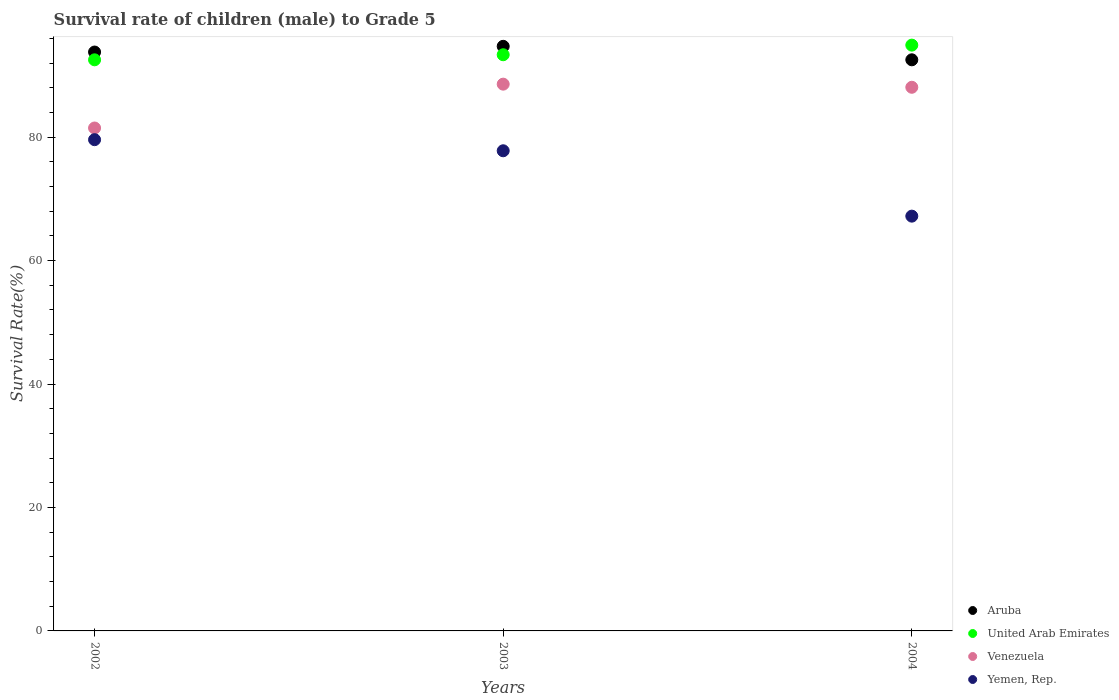How many different coloured dotlines are there?
Ensure brevity in your answer.  4. Is the number of dotlines equal to the number of legend labels?
Your response must be concise. Yes. What is the survival rate of male children to grade 5 in United Arab Emirates in 2004?
Ensure brevity in your answer.  94.91. Across all years, what is the maximum survival rate of male children to grade 5 in Venezuela?
Your response must be concise. 88.59. Across all years, what is the minimum survival rate of male children to grade 5 in Aruba?
Your answer should be compact. 92.53. What is the total survival rate of male children to grade 5 in Yemen, Rep. in the graph?
Offer a terse response. 224.59. What is the difference between the survival rate of male children to grade 5 in Aruba in 2002 and that in 2003?
Make the answer very short. -0.93. What is the difference between the survival rate of male children to grade 5 in Venezuela in 2004 and the survival rate of male children to grade 5 in Aruba in 2002?
Keep it short and to the point. -5.71. What is the average survival rate of male children to grade 5 in Yemen, Rep. per year?
Offer a terse response. 74.86. In the year 2004, what is the difference between the survival rate of male children to grade 5 in Yemen, Rep. and survival rate of male children to grade 5 in United Arab Emirates?
Your answer should be compact. -27.71. What is the ratio of the survival rate of male children to grade 5 in United Arab Emirates in 2002 to that in 2003?
Ensure brevity in your answer.  0.99. Is the survival rate of male children to grade 5 in Aruba in 2002 less than that in 2004?
Your response must be concise. No. What is the difference between the highest and the second highest survival rate of male children to grade 5 in United Arab Emirates?
Your answer should be very brief. 1.56. What is the difference between the highest and the lowest survival rate of male children to grade 5 in Aruba?
Provide a succinct answer. 2.18. Is it the case that in every year, the sum of the survival rate of male children to grade 5 in Venezuela and survival rate of male children to grade 5 in Aruba  is greater than the survival rate of male children to grade 5 in United Arab Emirates?
Your response must be concise. Yes. Does the survival rate of male children to grade 5 in Venezuela monotonically increase over the years?
Your answer should be compact. No. Is the survival rate of male children to grade 5 in Yemen, Rep. strictly greater than the survival rate of male children to grade 5 in United Arab Emirates over the years?
Offer a terse response. No. How many dotlines are there?
Make the answer very short. 4. Are the values on the major ticks of Y-axis written in scientific E-notation?
Offer a very short reply. No. Does the graph contain any zero values?
Your response must be concise. No. How many legend labels are there?
Make the answer very short. 4. How are the legend labels stacked?
Give a very brief answer. Vertical. What is the title of the graph?
Your answer should be compact. Survival rate of children (male) to Grade 5. What is the label or title of the X-axis?
Offer a terse response. Years. What is the label or title of the Y-axis?
Provide a short and direct response. Survival Rate(%). What is the Survival Rate(%) in Aruba in 2002?
Your answer should be very brief. 93.79. What is the Survival Rate(%) in United Arab Emirates in 2002?
Your response must be concise. 92.53. What is the Survival Rate(%) in Venezuela in 2002?
Your response must be concise. 81.48. What is the Survival Rate(%) in Yemen, Rep. in 2002?
Offer a terse response. 79.59. What is the Survival Rate(%) of Aruba in 2003?
Your answer should be compact. 94.72. What is the Survival Rate(%) of United Arab Emirates in 2003?
Your answer should be compact. 93.35. What is the Survival Rate(%) of Venezuela in 2003?
Provide a succinct answer. 88.59. What is the Survival Rate(%) in Yemen, Rep. in 2003?
Your response must be concise. 77.79. What is the Survival Rate(%) of Aruba in 2004?
Provide a short and direct response. 92.53. What is the Survival Rate(%) in United Arab Emirates in 2004?
Your answer should be very brief. 94.91. What is the Survival Rate(%) in Venezuela in 2004?
Offer a very short reply. 88.08. What is the Survival Rate(%) of Yemen, Rep. in 2004?
Keep it short and to the point. 67.2. Across all years, what is the maximum Survival Rate(%) of Aruba?
Provide a short and direct response. 94.72. Across all years, what is the maximum Survival Rate(%) in United Arab Emirates?
Provide a succinct answer. 94.91. Across all years, what is the maximum Survival Rate(%) of Venezuela?
Offer a terse response. 88.59. Across all years, what is the maximum Survival Rate(%) in Yemen, Rep.?
Ensure brevity in your answer.  79.59. Across all years, what is the minimum Survival Rate(%) in Aruba?
Offer a very short reply. 92.53. Across all years, what is the minimum Survival Rate(%) of United Arab Emirates?
Your response must be concise. 92.53. Across all years, what is the minimum Survival Rate(%) in Venezuela?
Offer a very short reply. 81.48. Across all years, what is the minimum Survival Rate(%) in Yemen, Rep.?
Make the answer very short. 67.2. What is the total Survival Rate(%) of Aruba in the graph?
Ensure brevity in your answer.  281.04. What is the total Survival Rate(%) of United Arab Emirates in the graph?
Your answer should be compact. 280.79. What is the total Survival Rate(%) of Venezuela in the graph?
Provide a succinct answer. 258.15. What is the total Survival Rate(%) in Yemen, Rep. in the graph?
Ensure brevity in your answer.  224.59. What is the difference between the Survival Rate(%) of Aruba in 2002 and that in 2003?
Provide a short and direct response. -0.93. What is the difference between the Survival Rate(%) in United Arab Emirates in 2002 and that in 2003?
Your response must be concise. -0.82. What is the difference between the Survival Rate(%) in Venezuela in 2002 and that in 2003?
Your answer should be compact. -7.1. What is the difference between the Survival Rate(%) of Yemen, Rep. in 2002 and that in 2003?
Give a very brief answer. 1.8. What is the difference between the Survival Rate(%) in Aruba in 2002 and that in 2004?
Your response must be concise. 1.26. What is the difference between the Survival Rate(%) of United Arab Emirates in 2002 and that in 2004?
Your answer should be compact. -2.38. What is the difference between the Survival Rate(%) of Venezuela in 2002 and that in 2004?
Provide a short and direct response. -6.6. What is the difference between the Survival Rate(%) of Yemen, Rep. in 2002 and that in 2004?
Provide a succinct answer. 12.39. What is the difference between the Survival Rate(%) in Aruba in 2003 and that in 2004?
Ensure brevity in your answer.  2.18. What is the difference between the Survival Rate(%) of United Arab Emirates in 2003 and that in 2004?
Keep it short and to the point. -1.56. What is the difference between the Survival Rate(%) of Venezuela in 2003 and that in 2004?
Provide a succinct answer. 0.51. What is the difference between the Survival Rate(%) in Yemen, Rep. in 2003 and that in 2004?
Offer a terse response. 10.59. What is the difference between the Survival Rate(%) in Aruba in 2002 and the Survival Rate(%) in United Arab Emirates in 2003?
Your answer should be very brief. 0.44. What is the difference between the Survival Rate(%) in Aruba in 2002 and the Survival Rate(%) in Venezuela in 2003?
Provide a succinct answer. 5.2. What is the difference between the Survival Rate(%) in Aruba in 2002 and the Survival Rate(%) in Yemen, Rep. in 2003?
Make the answer very short. 16. What is the difference between the Survival Rate(%) in United Arab Emirates in 2002 and the Survival Rate(%) in Venezuela in 2003?
Ensure brevity in your answer.  3.94. What is the difference between the Survival Rate(%) in United Arab Emirates in 2002 and the Survival Rate(%) in Yemen, Rep. in 2003?
Your response must be concise. 14.74. What is the difference between the Survival Rate(%) in Venezuela in 2002 and the Survival Rate(%) in Yemen, Rep. in 2003?
Your answer should be very brief. 3.69. What is the difference between the Survival Rate(%) of Aruba in 2002 and the Survival Rate(%) of United Arab Emirates in 2004?
Your response must be concise. -1.12. What is the difference between the Survival Rate(%) of Aruba in 2002 and the Survival Rate(%) of Venezuela in 2004?
Your response must be concise. 5.71. What is the difference between the Survival Rate(%) in Aruba in 2002 and the Survival Rate(%) in Yemen, Rep. in 2004?
Provide a succinct answer. 26.59. What is the difference between the Survival Rate(%) in United Arab Emirates in 2002 and the Survival Rate(%) in Venezuela in 2004?
Make the answer very short. 4.45. What is the difference between the Survival Rate(%) of United Arab Emirates in 2002 and the Survival Rate(%) of Yemen, Rep. in 2004?
Offer a very short reply. 25.33. What is the difference between the Survival Rate(%) of Venezuela in 2002 and the Survival Rate(%) of Yemen, Rep. in 2004?
Keep it short and to the point. 14.28. What is the difference between the Survival Rate(%) of Aruba in 2003 and the Survival Rate(%) of United Arab Emirates in 2004?
Provide a succinct answer. -0.19. What is the difference between the Survival Rate(%) of Aruba in 2003 and the Survival Rate(%) of Venezuela in 2004?
Keep it short and to the point. 6.64. What is the difference between the Survival Rate(%) in Aruba in 2003 and the Survival Rate(%) in Yemen, Rep. in 2004?
Offer a terse response. 27.51. What is the difference between the Survival Rate(%) in United Arab Emirates in 2003 and the Survival Rate(%) in Venezuela in 2004?
Your response must be concise. 5.27. What is the difference between the Survival Rate(%) of United Arab Emirates in 2003 and the Survival Rate(%) of Yemen, Rep. in 2004?
Offer a terse response. 26.15. What is the difference between the Survival Rate(%) in Venezuela in 2003 and the Survival Rate(%) in Yemen, Rep. in 2004?
Provide a short and direct response. 21.38. What is the average Survival Rate(%) in Aruba per year?
Give a very brief answer. 93.68. What is the average Survival Rate(%) in United Arab Emirates per year?
Make the answer very short. 93.6. What is the average Survival Rate(%) of Venezuela per year?
Provide a succinct answer. 86.05. What is the average Survival Rate(%) of Yemen, Rep. per year?
Your response must be concise. 74.86. In the year 2002, what is the difference between the Survival Rate(%) of Aruba and Survival Rate(%) of United Arab Emirates?
Keep it short and to the point. 1.26. In the year 2002, what is the difference between the Survival Rate(%) of Aruba and Survival Rate(%) of Venezuela?
Ensure brevity in your answer.  12.31. In the year 2002, what is the difference between the Survival Rate(%) in Aruba and Survival Rate(%) in Yemen, Rep.?
Your answer should be very brief. 14.2. In the year 2002, what is the difference between the Survival Rate(%) in United Arab Emirates and Survival Rate(%) in Venezuela?
Provide a short and direct response. 11.05. In the year 2002, what is the difference between the Survival Rate(%) in United Arab Emirates and Survival Rate(%) in Yemen, Rep.?
Keep it short and to the point. 12.94. In the year 2002, what is the difference between the Survival Rate(%) of Venezuela and Survival Rate(%) of Yemen, Rep.?
Provide a short and direct response. 1.89. In the year 2003, what is the difference between the Survival Rate(%) in Aruba and Survival Rate(%) in United Arab Emirates?
Make the answer very short. 1.36. In the year 2003, what is the difference between the Survival Rate(%) of Aruba and Survival Rate(%) of Venezuela?
Give a very brief answer. 6.13. In the year 2003, what is the difference between the Survival Rate(%) of Aruba and Survival Rate(%) of Yemen, Rep.?
Provide a succinct answer. 16.92. In the year 2003, what is the difference between the Survival Rate(%) in United Arab Emirates and Survival Rate(%) in Venezuela?
Offer a very short reply. 4.77. In the year 2003, what is the difference between the Survival Rate(%) in United Arab Emirates and Survival Rate(%) in Yemen, Rep.?
Offer a terse response. 15.56. In the year 2003, what is the difference between the Survival Rate(%) in Venezuela and Survival Rate(%) in Yemen, Rep.?
Offer a very short reply. 10.79. In the year 2004, what is the difference between the Survival Rate(%) in Aruba and Survival Rate(%) in United Arab Emirates?
Offer a terse response. -2.38. In the year 2004, what is the difference between the Survival Rate(%) of Aruba and Survival Rate(%) of Venezuela?
Offer a terse response. 4.45. In the year 2004, what is the difference between the Survival Rate(%) of Aruba and Survival Rate(%) of Yemen, Rep.?
Your answer should be compact. 25.33. In the year 2004, what is the difference between the Survival Rate(%) in United Arab Emirates and Survival Rate(%) in Venezuela?
Keep it short and to the point. 6.83. In the year 2004, what is the difference between the Survival Rate(%) in United Arab Emirates and Survival Rate(%) in Yemen, Rep.?
Your answer should be very brief. 27.71. In the year 2004, what is the difference between the Survival Rate(%) in Venezuela and Survival Rate(%) in Yemen, Rep.?
Give a very brief answer. 20.88. What is the ratio of the Survival Rate(%) in Aruba in 2002 to that in 2003?
Make the answer very short. 0.99. What is the ratio of the Survival Rate(%) of United Arab Emirates in 2002 to that in 2003?
Provide a succinct answer. 0.99. What is the ratio of the Survival Rate(%) of Venezuela in 2002 to that in 2003?
Keep it short and to the point. 0.92. What is the ratio of the Survival Rate(%) in Yemen, Rep. in 2002 to that in 2003?
Your answer should be very brief. 1.02. What is the ratio of the Survival Rate(%) of Aruba in 2002 to that in 2004?
Make the answer very short. 1.01. What is the ratio of the Survival Rate(%) in United Arab Emirates in 2002 to that in 2004?
Offer a very short reply. 0.97. What is the ratio of the Survival Rate(%) of Venezuela in 2002 to that in 2004?
Keep it short and to the point. 0.93. What is the ratio of the Survival Rate(%) of Yemen, Rep. in 2002 to that in 2004?
Make the answer very short. 1.18. What is the ratio of the Survival Rate(%) of Aruba in 2003 to that in 2004?
Provide a short and direct response. 1.02. What is the ratio of the Survival Rate(%) of United Arab Emirates in 2003 to that in 2004?
Provide a succinct answer. 0.98. What is the ratio of the Survival Rate(%) of Yemen, Rep. in 2003 to that in 2004?
Your response must be concise. 1.16. What is the difference between the highest and the second highest Survival Rate(%) in Aruba?
Your answer should be very brief. 0.93. What is the difference between the highest and the second highest Survival Rate(%) of United Arab Emirates?
Give a very brief answer. 1.56. What is the difference between the highest and the second highest Survival Rate(%) of Venezuela?
Offer a terse response. 0.51. What is the difference between the highest and the second highest Survival Rate(%) of Yemen, Rep.?
Offer a terse response. 1.8. What is the difference between the highest and the lowest Survival Rate(%) of Aruba?
Make the answer very short. 2.18. What is the difference between the highest and the lowest Survival Rate(%) in United Arab Emirates?
Make the answer very short. 2.38. What is the difference between the highest and the lowest Survival Rate(%) in Venezuela?
Your response must be concise. 7.1. What is the difference between the highest and the lowest Survival Rate(%) in Yemen, Rep.?
Offer a terse response. 12.39. 